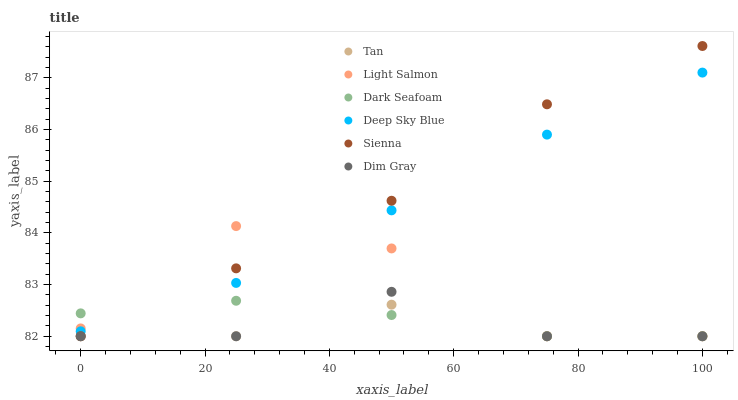Does Tan have the minimum area under the curve?
Answer yes or no. Yes. Does Sienna have the maximum area under the curve?
Answer yes or no. Yes. Does Dim Gray have the minimum area under the curve?
Answer yes or no. No. Does Dim Gray have the maximum area under the curve?
Answer yes or no. No. Is Deep Sky Blue the smoothest?
Answer yes or no. Yes. Is Light Salmon the roughest?
Answer yes or no. Yes. Is Dim Gray the smoothest?
Answer yes or no. No. Is Dim Gray the roughest?
Answer yes or no. No. Does Light Salmon have the lowest value?
Answer yes or no. Yes. Does Deep Sky Blue have the lowest value?
Answer yes or no. No. Does Sienna have the highest value?
Answer yes or no. Yes. Does Dim Gray have the highest value?
Answer yes or no. No. Is Tan less than Deep Sky Blue?
Answer yes or no. Yes. Is Deep Sky Blue greater than Tan?
Answer yes or no. Yes. Does Dark Seafoam intersect Sienna?
Answer yes or no. Yes. Is Dark Seafoam less than Sienna?
Answer yes or no. No. Is Dark Seafoam greater than Sienna?
Answer yes or no. No. Does Tan intersect Deep Sky Blue?
Answer yes or no. No. 